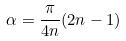<formula> <loc_0><loc_0><loc_500><loc_500>\alpha = \frac { \pi } { 4 n } ( 2 n - 1 )</formula> 